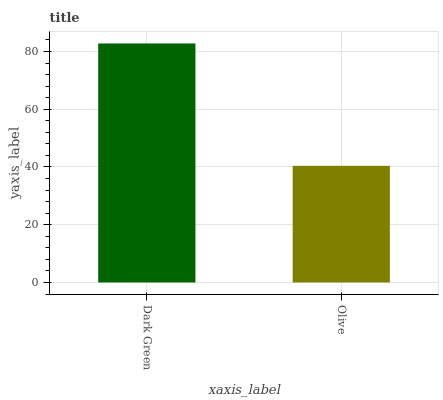Is Olive the minimum?
Answer yes or no. Yes. Is Dark Green the maximum?
Answer yes or no. Yes. Is Olive the maximum?
Answer yes or no. No. Is Dark Green greater than Olive?
Answer yes or no. Yes. Is Olive less than Dark Green?
Answer yes or no. Yes. Is Olive greater than Dark Green?
Answer yes or no. No. Is Dark Green less than Olive?
Answer yes or no. No. Is Dark Green the high median?
Answer yes or no. Yes. Is Olive the low median?
Answer yes or no. Yes. Is Olive the high median?
Answer yes or no. No. Is Dark Green the low median?
Answer yes or no. No. 